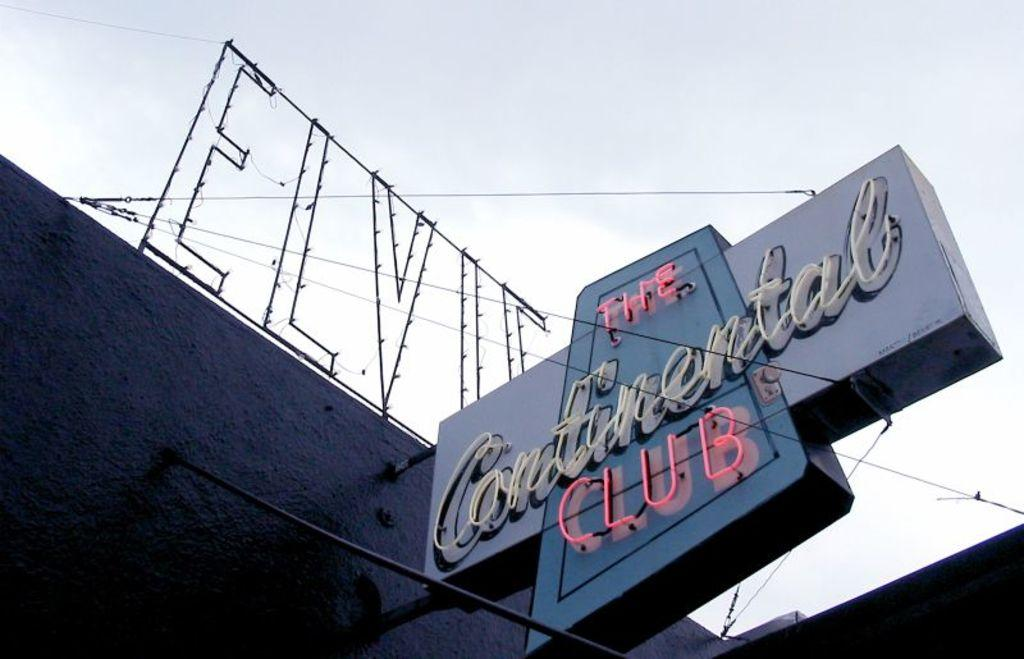<image>
Offer a succinct explanation of the picture presented. A sign for The Continental Club with Elvis' name above it 